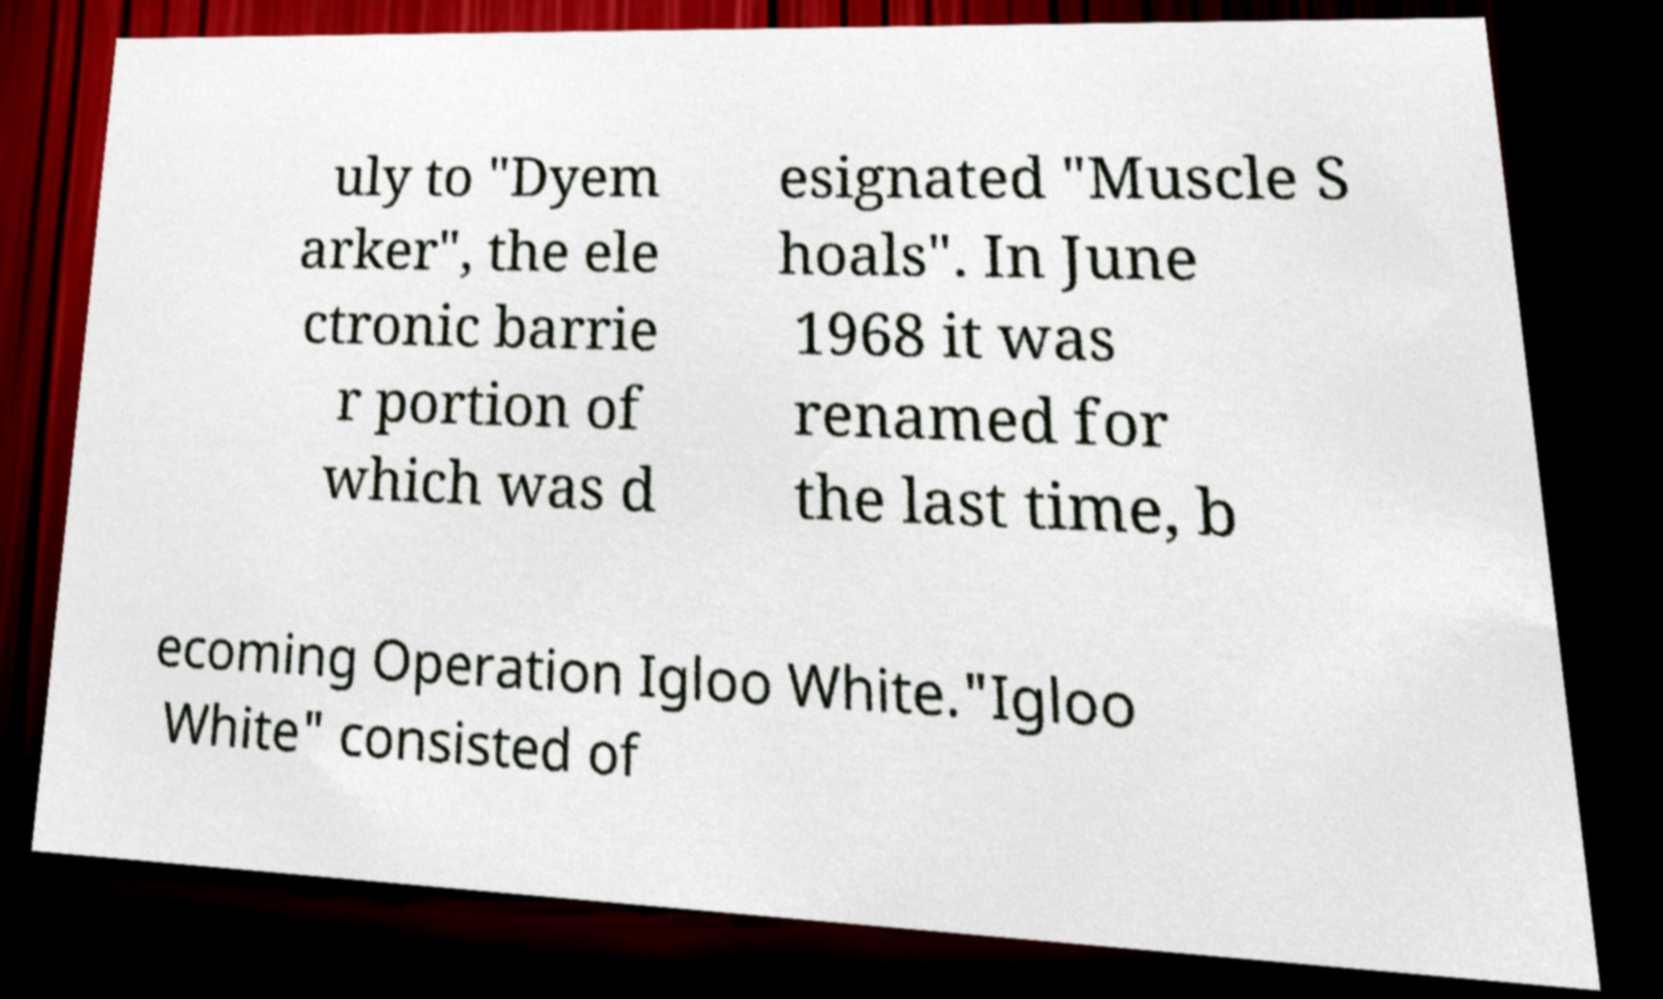What messages or text are displayed in this image? I need them in a readable, typed format. uly to "Dyem arker", the ele ctronic barrie r portion of which was d esignated "Muscle S hoals". In June 1968 it was renamed for the last time, b ecoming Operation Igloo White."Igloo White" consisted of 